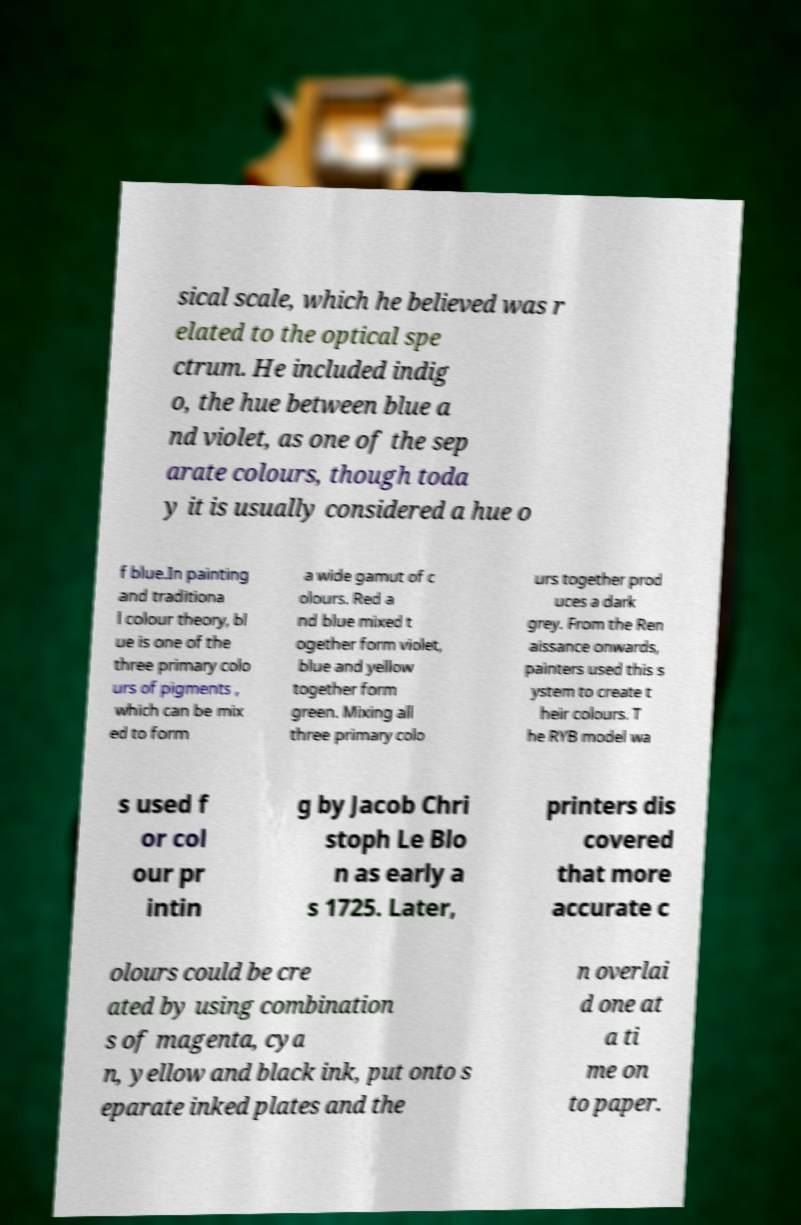Please read and relay the text visible in this image. What does it say? sical scale, which he believed was r elated to the optical spe ctrum. He included indig o, the hue between blue a nd violet, as one of the sep arate colours, though toda y it is usually considered a hue o f blue.In painting and traditiona l colour theory, bl ue is one of the three primary colo urs of pigments , which can be mix ed to form a wide gamut of c olours. Red a nd blue mixed t ogether form violet, blue and yellow together form green. Mixing all three primary colo urs together prod uces a dark grey. From the Ren aissance onwards, painters used this s ystem to create t heir colours. T he RYB model wa s used f or col our pr intin g by Jacob Chri stoph Le Blo n as early a s 1725. Later, printers dis covered that more accurate c olours could be cre ated by using combination s of magenta, cya n, yellow and black ink, put onto s eparate inked plates and the n overlai d one at a ti me on to paper. 